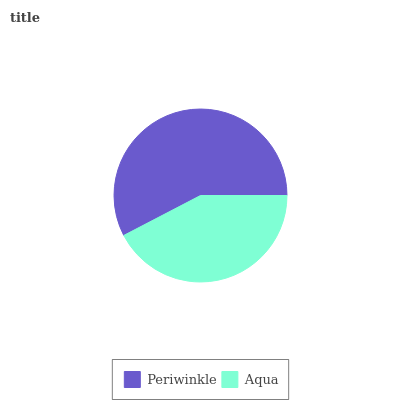Is Aqua the minimum?
Answer yes or no. Yes. Is Periwinkle the maximum?
Answer yes or no. Yes. Is Aqua the maximum?
Answer yes or no. No. Is Periwinkle greater than Aqua?
Answer yes or no. Yes. Is Aqua less than Periwinkle?
Answer yes or no. Yes. Is Aqua greater than Periwinkle?
Answer yes or no. No. Is Periwinkle less than Aqua?
Answer yes or no. No. Is Periwinkle the high median?
Answer yes or no. Yes. Is Aqua the low median?
Answer yes or no. Yes. Is Aqua the high median?
Answer yes or no. No. Is Periwinkle the low median?
Answer yes or no. No. 